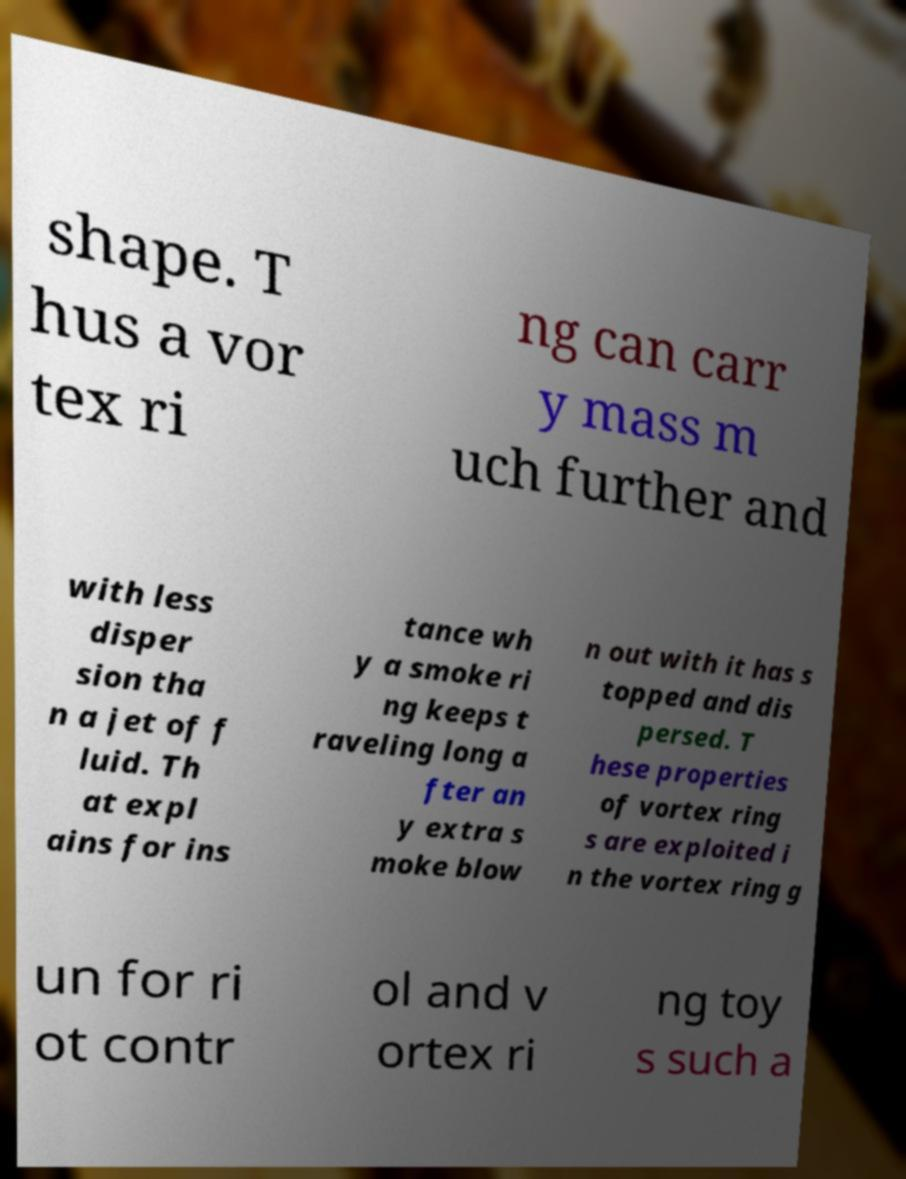There's text embedded in this image that I need extracted. Can you transcribe it verbatim? shape. T hus a vor tex ri ng can carr y mass m uch further and with less disper sion tha n a jet of f luid. Th at expl ains for ins tance wh y a smoke ri ng keeps t raveling long a fter an y extra s moke blow n out with it has s topped and dis persed. T hese properties of vortex ring s are exploited i n the vortex ring g un for ri ot contr ol and v ortex ri ng toy s such a 